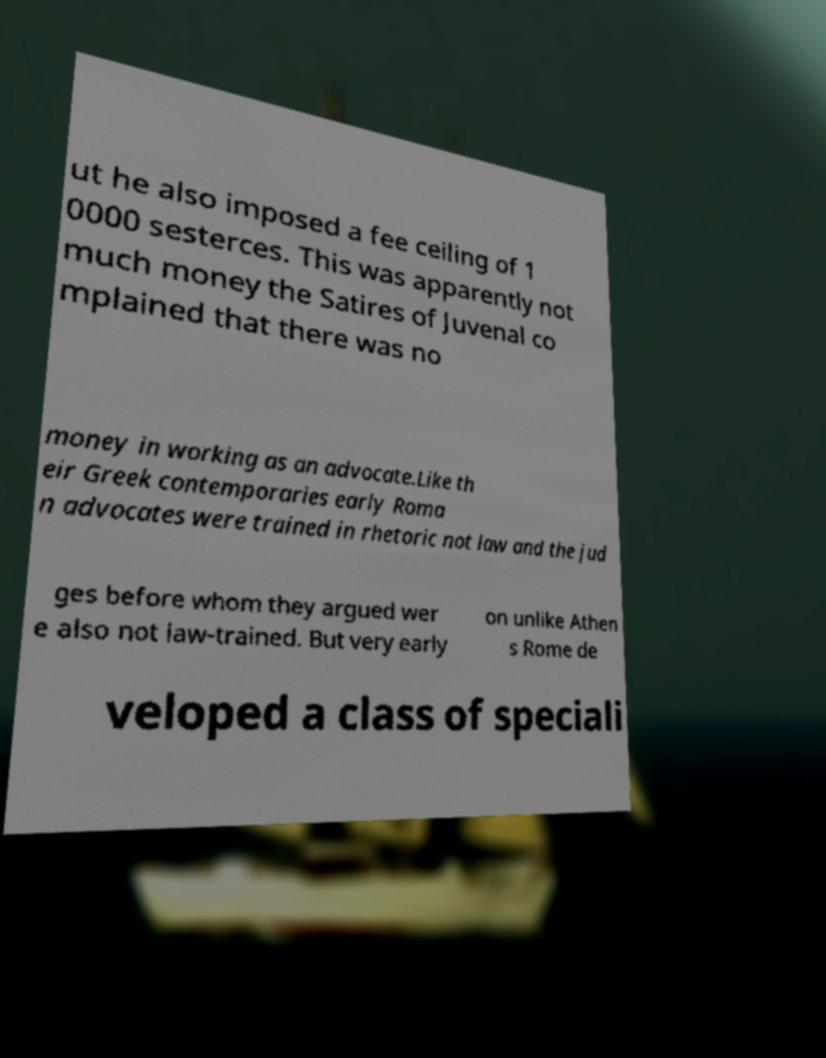Could you extract and type out the text from this image? ut he also imposed a fee ceiling of 1 0000 sesterces. This was apparently not much money the Satires of Juvenal co mplained that there was no money in working as an advocate.Like th eir Greek contemporaries early Roma n advocates were trained in rhetoric not law and the jud ges before whom they argued wer e also not law-trained. But very early on unlike Athen s Rome de veloped a class of speciali 